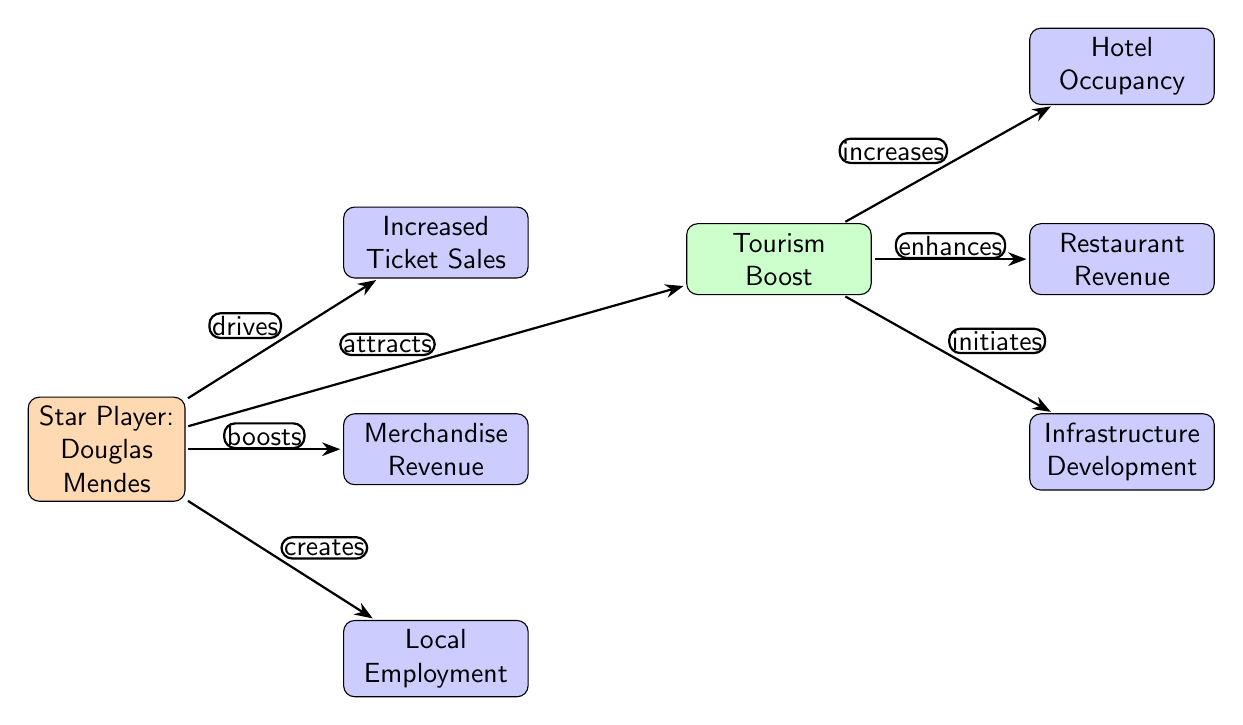What is the main node representing the star player? The main node labeled "Star Player: Douglas Mendes" identifies him as the focal point of the diagram.
Answer: Douglas Mendes How many effects are directly linked to the star player? There are three effects linked directly to Douglas Mendes, as indicated by the arrows going from the player to the nodes for increased ticket sales, merchandise revenue, and local employment.
Answer: 3 What type of impact does the star player have on ticket sales? The diagram shows that the star player "drives" increased ticket sales, meaning he is a motivating factor for higher sales.
Answer: drives What does the tourism node lead to in terms of local businesses? The tourism node leads to three outcomes: hotel occupancy, restaurant revenue, and infrastructure development, indicating how tourism positively impacts local businesses.
Answer: hotel occupancy, restaurant revenue, infrastructure development Which effect is indicated as creating local employment? The node labeled "Local Employment" suggests that the presence of Douglas Mendes contributes to job opportunities within the community.
Answer: Local Employment What is the relationship between tourism and restaurant revenue? The tourism node "enhances" restaurant revenue, demonstrating that increased tourism positively impacts the revenue local restaurants earn.
Answer: enhances How many edges are in the diagram? By counting the arrows connecting the nodes, there are a total of six edges in the diagram indicating the flow of impact from the star player and tourism to various effects.
Answer: 6 What kind of impact does tourism have on hotel occupancy? Tourism "increases" hotel occupancy, showing that more visitors lead to higher occupancy rates in local hotels.
Answer: increases What node corresponds to the increased merchandise revenue? The node labeled "Merchandise Revenue" corresponds to the financial gain stemming from the popularity of the star player and associated sales.
Answer: Merchandise Revenue Which node illustrates a boost to the local economy through public appearances? The tourism node reflects the overall boost to the local economy, indicating that public appearances and the star player's presence attract visitors.
Answer: Tourism Boost 